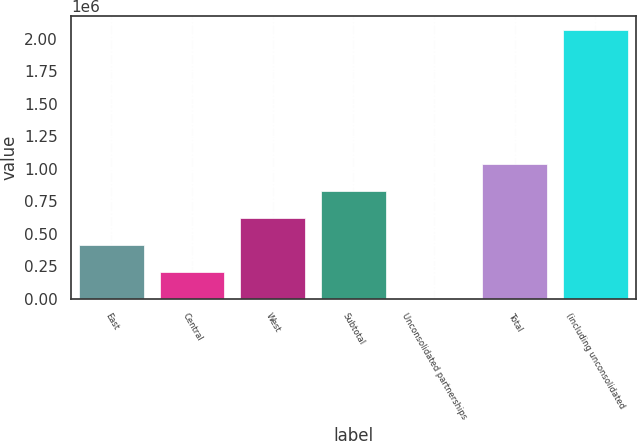<chart> <loc_0><loc_0><loc_500><loc_500><bar_chart><fcel>East<fcel>Central<fcel>West<fcel>Subtotal<fcel>Unconsolidated partnerships<fcel>Total<fcel>(including unconsolidated<nl><fcel>414674<fcel>207508<fcel>621839<fcel>829005<fcel>342<fcel>1.03617e+06<fcel>2.072e+06<nl></chart> 